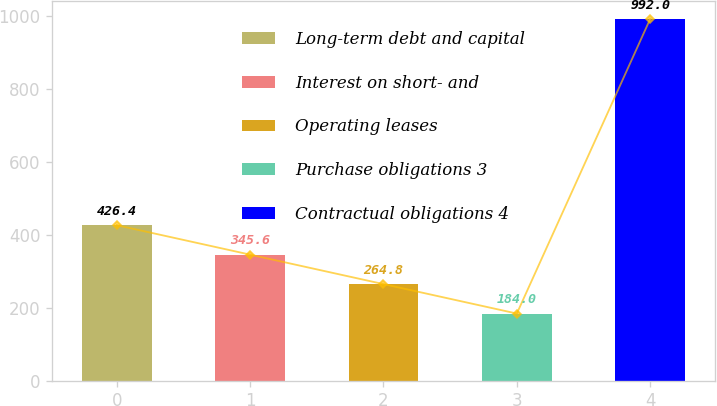Convert chart to OTSL. <chart><loc_0><loc_0><loc_500><loc_500><bar_chart><fcel>Long-term debt and capital<fcel>Interest on short- and<fcel>Operating leases<fcel>Purchase obligations 3<fcel>Contractual obligations 4<nl><fcel>426.4<fcel>345.6<fcel>264.8<fcel>184<fcel>992<nl></chart> 